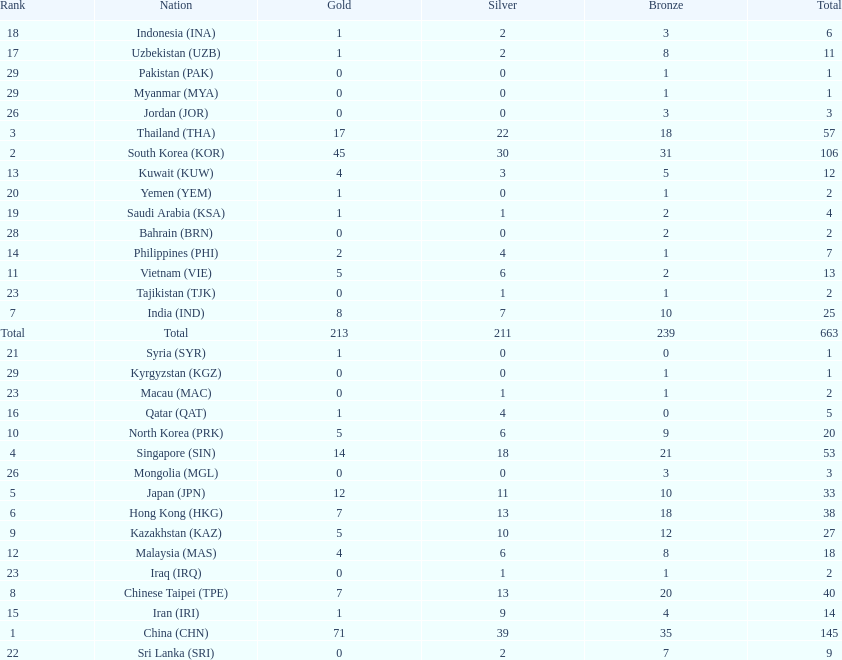How many nations earned at least ten bronze medals? 9. 